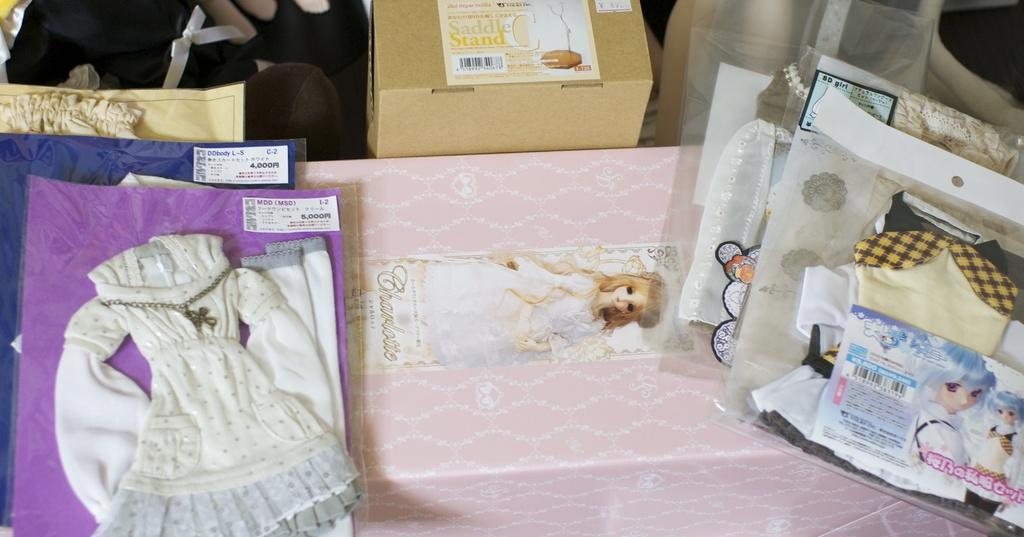What type of objects can be seen in the image? There are boxes in the image. Can you describe the appearance of the boxes? The boxes are pink and brown in color. What else is present in the image besides the boxes? There are packets with clothes in the image. Are there any other objects visible in the image? Yes, there are other objects in the image. Where can the market be found in the image? There is no market present in the image. Can you see anyone sleeping in the image? There is no one sleeping in the image. 